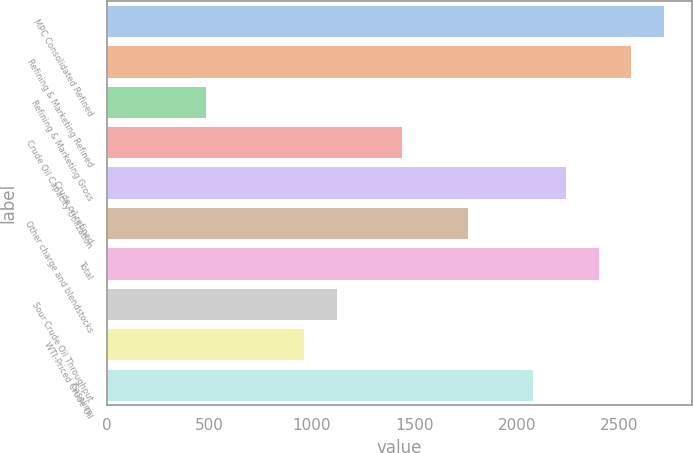Convert chart. <chart><loc_0><loc_0><loc_500><loc_500><bar_chart><fcel>MPC Consolidated Refined<fcel>Refining & Marketing Refined<fcel>Refining & Marketing Gross<fcel>Crude Oil Capacity Utilization<fcel>Crude oil refined<fcel>Other charge and blendstocks<fcel>Total<fcel>Sour Crude Oil Throughput<fcel>WTI-Priced Crude Oil<fcel>Gasoline<nl><fcel>2717.72<fcel>2557.9<fcel>480.24<fcel>1439.16<fcel>2238.26<fcel>1758.8<fcel>2398.08<fcel>1119.52<fcel>959.7<fcel>2078.44<nl></chart> 